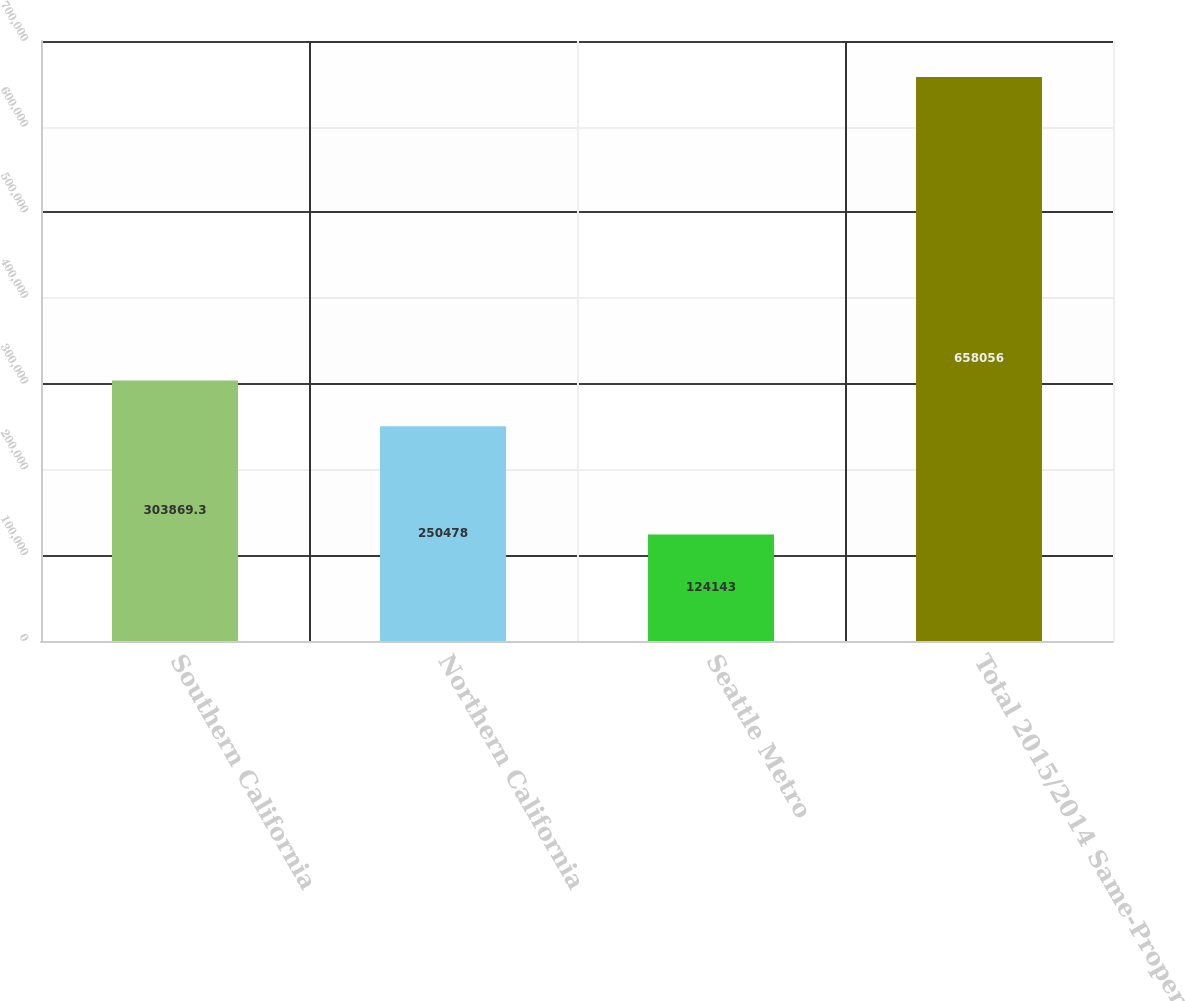<chart> <loc_0><loc_0><loc_500><loc_500><bar_chart><fcel>Southern California<fcel>Northern California<fcel>Seattle Metro<fcel>Total 2015/2014 Same-Property<nl><fcel>303869<fcel>250478<fcel>124143<fcel>658056<nl></chart> 